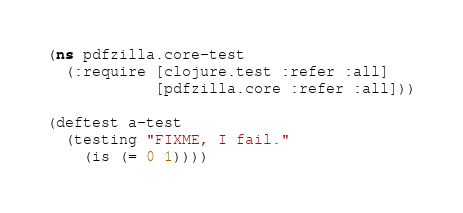<code> <loc_0><loc_0><loc_500><loc_500><_Clojure_>(ns pdfzilla.core-test
  (:require [clojure.test :refer :all]
            [pdfzilla.core :refer :all]))

(deftest a-test
  (testing "FIXME, I fail."
    (is (= 0 1))))
</code> 